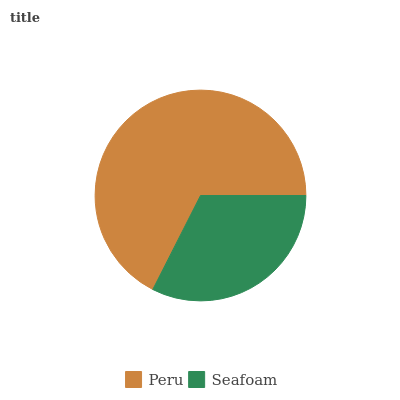Is Seafoam the minimum?
Answer yes or no. Yes. Is Peru the maximum?
Answer yes or no. Yes. Is Seafoam the maximum?
Answer yes or no. No. Is Peru greater than Seafoam?
Answer yes or no. Yes. Is Seafoam less than Peru?
Answer yes or no. Yes. Is Seafoam greater than Peru?
Answer yes or no. No. Is Peru less than Seafoam?
Answer yes or no. No. Is Peru the high median?
Answer yes or no. Yes. Is Seafoam the low median?
Answer yes or no. Yes. Is Seafoam the high median?
Answer yes or no. No. Is Peru the low median?
Answer yes or no. No. 